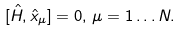Convert formula to latex. <formula><loc_0><loc_0><loc_500><loc_500>[ { \hat { H } } , { \hat { x } } _ { \mu } ] = 0 , \, \mu = 1 \dots N .</formula> 